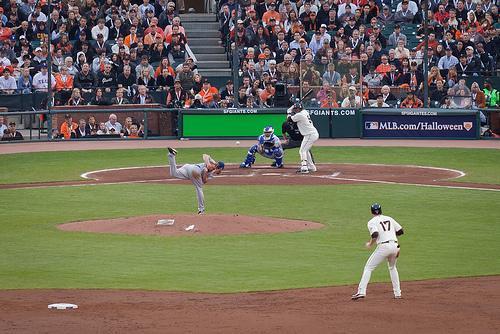How many men are on the field?
Give a very brief answer. 5. 